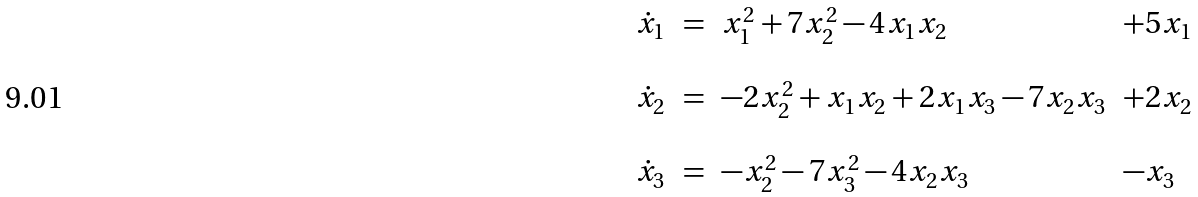<formula> <loc_0><loc_0><loc_500><loc_500>\begin{array} { c c l l } \dot { x } _ { 1 } & = & x _ { 1 } ^ { 2 } + 7 x _ { 2 } ^ { 2 } - 4 x _ { 1 } x _ { 2 } & + 5 x _ { 1 } \\ & & & \\ \dot { x } _ { 2 } & = & - 2 x _ { 2 } ^ { 2 } + x _ { 1 } x _ { 2 } + 2 x _ { 1 } x _ { 3 } - 7 x _ { 2 } x _ { 3 } & + 2 x _ { 2 } \\ & & & \\ \dot { x } _ { 3 } & = & - x _ { 2 } ^ { 2 } - 7 x _ { 3 } ^ { 2 } - 4 x _ { 2 } x _ { 3 } & - x _ { 3 } \end{array}</formula> 